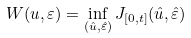Convert formula to latex. <formula><loc_0><loc_0><loc_500><loc_500>W ( u , \varepsilon ) = \inf _ { ( { \hat { u } } , { \hat { \varepsilon } } ) } J _ { [ 0 , t ] } ( { \hat { u } } , { \hat { \varepsilon } } )</formula> 